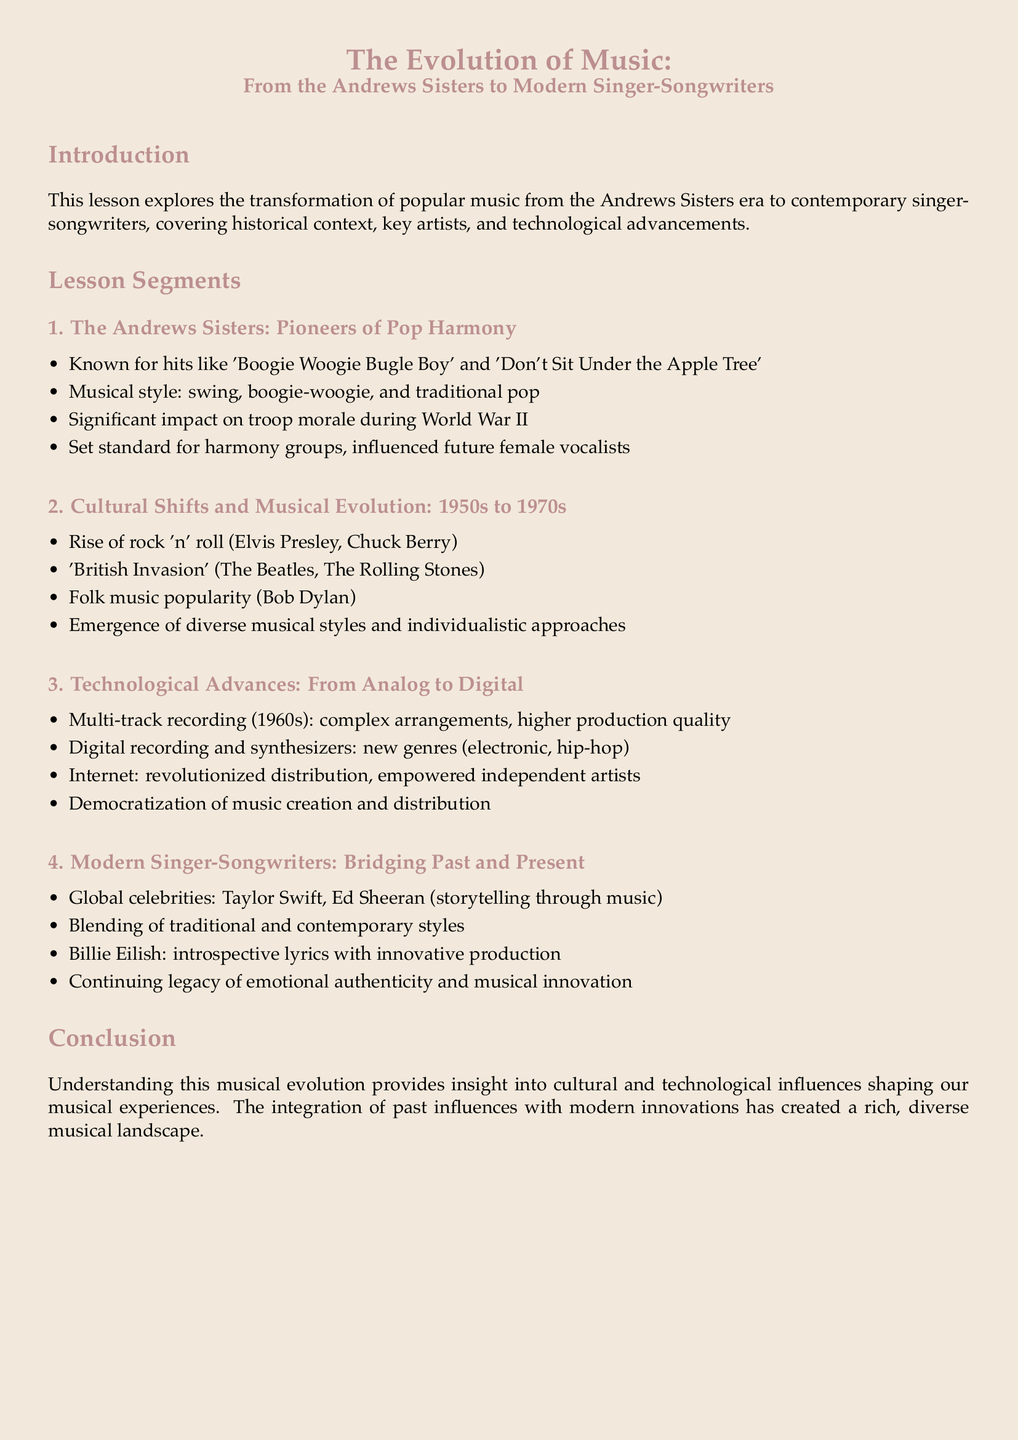What is the title of the lesson? The title is the main heading of the lesson plan, highlighting the focus on music evolution.
Answer: The Evolution of Music: From the Andrews Sisters to Modern Singer-Songwriters Who were known for the hit "Boogie Woogie Bugle Boy"? This question seeks to identify the artists mentioned in the document who sang a famous song.
Answer: The Andrews Sisters Which musical styles are associated with the Andrews Sisters? This question is about the genres mentioned that represent the Andrews Sisters' music style.
Answer: Swing, boogie-woogie, and traditional pop What technological advancement in the 1960s allowed for complex arrangements? This relates to specific technological changes mentioned in the lesson that improved music production capabilities.
Answer: Multi-track recording Name one artist mentioned from the 'British Invasion'. The British Invasion introduced new musical influences and this question asks for exemplification.
Answer: The Beatles What is one impact of the Internet on music? This question examines how the document discusses the influence of the Internet in music distribution.
Answer: Revolutionized distribution Who are two modern singer-songwriters mentioned? This question addresses current popular artists named in the lesson.
Answer: Taylor Swift, Ed Sheeran What aspect of modern music does Billie Eilish emphasize? This question looks for a specific characteristic related to a current artist discussed in the text.
Answer: Introspective lyrics What does understanding musical evolution provide insight into? This question probes for an overarching theme addressed in the conclusion of the lesson.
Answer: Cultural and technological influences 